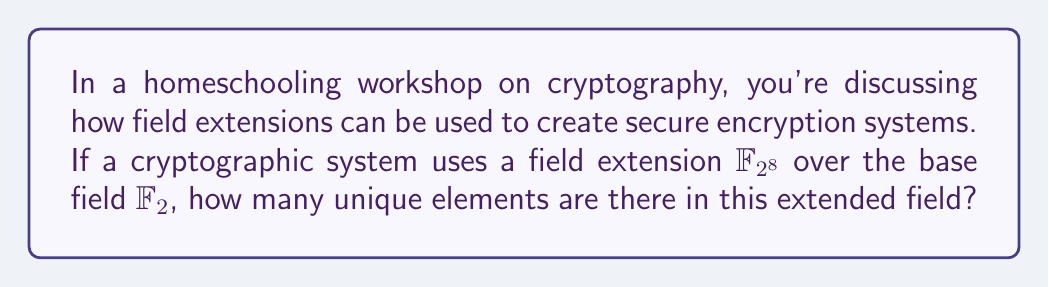Teach me how to tackle this problem. Let's approach this step-by-step:

1) The base field $\mathbb{F}_2$ is the field of integers modulo 2, containing only the elements {0, 1}.

2) The field extension $\mathbb{F}_{2^8}$ is created by extending $\mathbb{F}_2$ to a field with $2^8$ elements.

3) In general, if we have a field extension $\mathbb{F}_{p^n}$ where $p$ is prime and $n$ is a positive integer:
   - $p$ represents the characteristic of the field (in this case, 2)
   - $n$ represents the degree of the extension (in this case, 8)

4) The number of elements in a field extension $\mathbb{F}_{p^n}$ is always $p^n$.

5) Therefore, for $\mathbb{F}_{2^8}$, the number of elements is:

   $$2^8 = 2 \times 2 \times 2 \times 2 \times 2 \times 2 \times 2 \times 2 = 256$$

6) This means there are 256 unique elements in the field extension $\mathbb{F}_{2^8}$.

In cryptography, this larger field provides more possible values for encryption, increasing the complexity and security of the system compared to using just the base field $\mathbb{F}_2$.
Answer: 256 